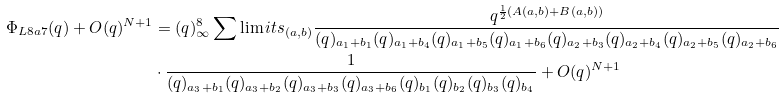<formula> <loc_0><loc_0><loc_500><loc_500>\Phi _ { L 8 a 7 } ( q ) + O ( q ) ^ { N + 1 } & = ( q ) _ { \infty } ^ { 8 } \sum \lim i t s _ { ( a , b ) } \frac { q ^ { \frac { 1 } { 2 } ( A ( a , b ) + B ( a , b ) ) } } { ( q ) _ { a _ { 1 } + b _ { 1 } } ( q ) _ { a _ { 1 } + b _ { 4 } } ( q ) _ { a _ { 1 } + b _ { 5 } } ( q ) _ { a _ { 1 } + b _ { 6 } } ( q ) _ { a _ { 2 } + b _ { 3 } } ( q ) _ { a _ { 2 } + b _ { 4 } } ( q ) _ { a _ { 2 } + b _ { 5 } } ( q ) _ { a _ { 2 } + b _ { 6 } } } \\ & \cdot \frac { 1 } { ( q ) _ { a _ { 3 } + b _ { 1 } } ( q ) _ { a _ { 3 } + b _ { 2 } } ( q ) _ { a _ { 3 } + b _ { 3 } } ( q ) _ { a _ { 3 } + b _ { 6 } } ( q ) _ { b _ { 1 } } ( q ) _ { b _ { 2 } } ( q ) _ { b _ { 3 } } ( q ) _ { b _ { 4 } } } + O ( q ) ^ { N + 1 }</formula> 